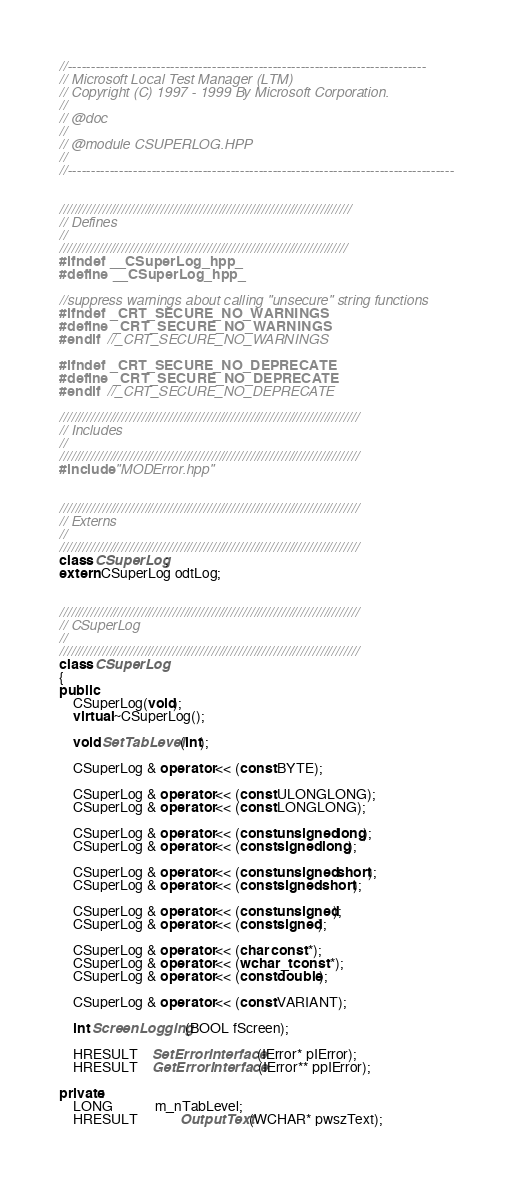Convert code to text. <code><loc_0><loc_0><loc_500><loc_500><_C++_>//-----------------------------------------------------------------------------
// Microsoft Local Test Manager (LTM)
// Copyright (C) 1997 - 1999 By Microsoft Corporation.
//	  
// @doc
//												  
// @module CSUPERLOG.HPP
//
//-----------------------------------------------------------------------------------


///////////////////////////////////////////////////////////////////////////
// Defines
//
//////////////////////////////////////////////////////////////////////////
#ifndef __CSuperLog_hpp_
#define __CSuperLog_hpp_

//suppress warnings about calling "unsecure" string functions
#ifndef _CRT_SECURE_NO_WARNINGS
#define _CRT_SECURE_NO_WARNINGS
#endif	//_CRT_SECURE_NO_WARNINGS

#ifndef _CRT_SECURE_NO_DEPRECATE
#define _CRT_SECURE_NO_DEPRECATE
#endif	//_CRT_SECURE_NO_DEPRECATE

/////////////////////////////////////////////////////////////////////////////
// Includes
//
/////////////////////////////////////////////////////////////////////////////
#include "MODError.hpp"


/////////////////////////////////////////////////////////////////////////////
// Externs
//
/////////////////////////////////////////////////////////////////////////////
class CSuperLog;
extern CSuperLog odtLog;


/////////////////////////////////////////////////////////////////////////////
// CSuperLog
//
/////////////////////////////////////////////////////////////////////////////
class CSuperLog
{
public:
	CSuperLog(void);
	virtual ~CSuperLog();

	void SetTabLevel(int);

	CSuperLog & operator << (const BYTE);

	CSuperLog & operator << (const ULONGLONG);
	CSuperLog & operator << (const LONGLONG);

	CSuperLog & operator << (const unsigned long);
	CSuperLog & operator << (const signed long);

	CSuperLog & operator << (const unsigned short);
	CSuperLog & operator << (const signed short);

	CSuperLog & operator << (const unsigned);
	CSuperLog & operator << (const signed);

	CSuperLog & operator << (char const *);
	CSuperLog & operator << (wchar_t const *);
	CSuperLog & operator << (const double);

	CSuperLog & operator << (const VARIANT);

	int ScreenLogging(BOOL fScreen);

	HRESULT	SetErrorInterface(IError* pIError);
	HRESULT	GetErrorInterface(IError** ppIError);

private:
	LONG			m_nTabLevel;
	HRESULT			OutputText(WCHAR* pwszText);
	</code> 